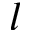<formula> <loc_0><loc_0><loc_500><loc_500>l</formula> 